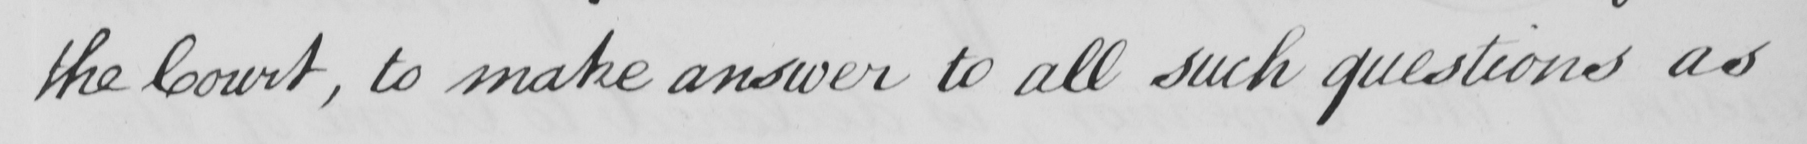What text is written in this handwritten line? the Court , to make answer to all such questions as 